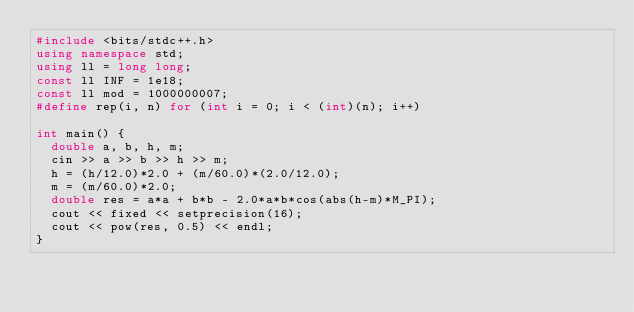Convert code to text. <code><loc_0><loc_0><loc_500><loc_500><_C++_>#include <bits/stdc++.h>
using namespace std;
using ll = long long;
const ll INF = 1e18;
const ll mod = 1000000007;
#define rep(i, n) for (int i = 0; i < (int)(n); i++)

int main() {
  double a, b, h, m;
  cin >> a >> b >> h >> m;
  h = (h/12.0)*2.0 + (m/60.0)*(2.0/12.0);
  m = (m/60.0)*2.0;
  double res = a*a + b*b - 2.0*a*b*cos(abs(h-m)*M_PI);
  cout << fixed << setprecision(16);
  cout << pow(res, 0.5) << endl;
}</code> 